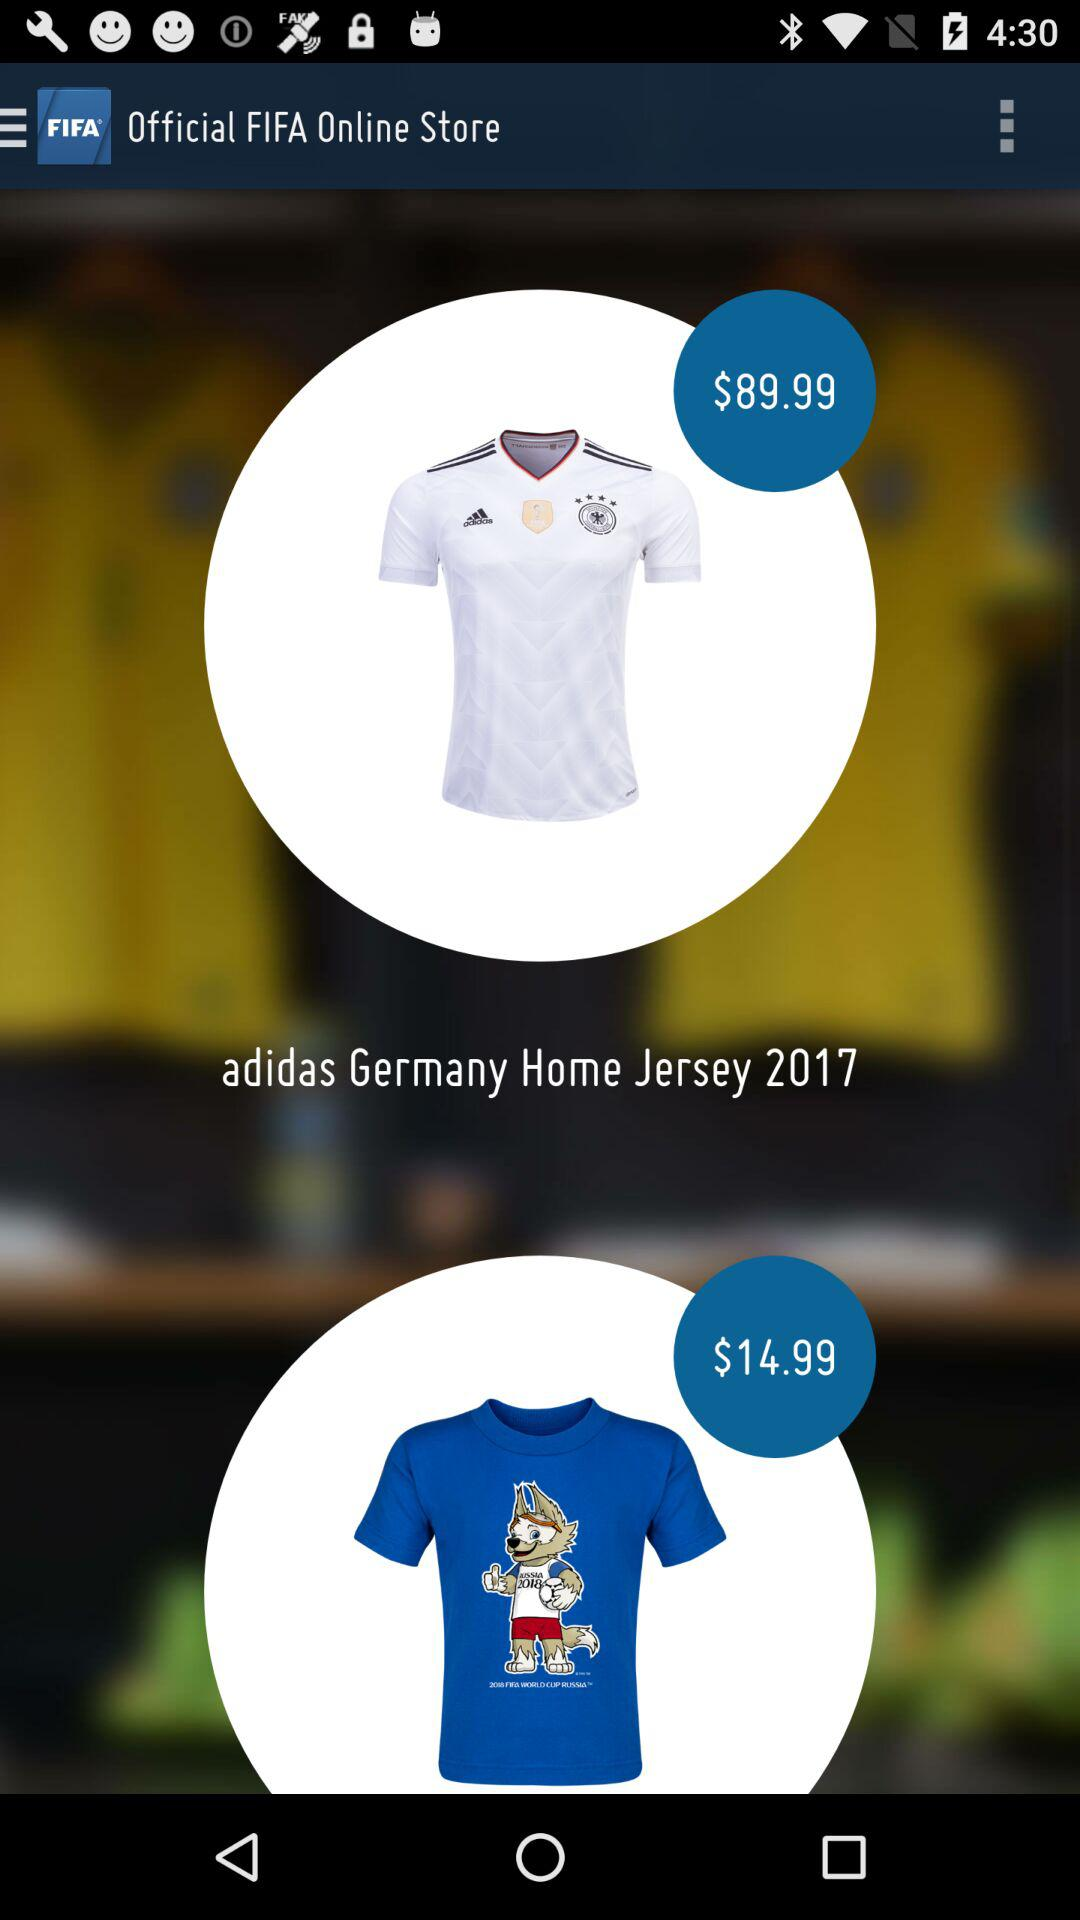What is the price of "adidas Germany Home Jersey 2017"? The price of "adidas Germany Home Jersey 2017" is $89.99. 